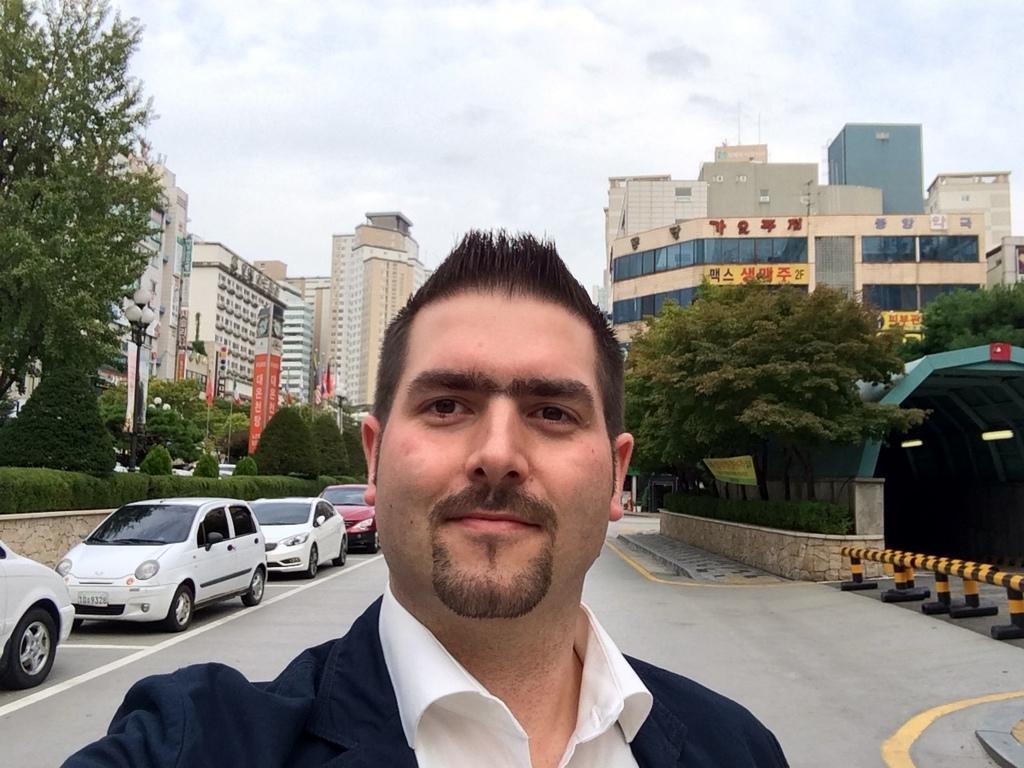How would you summarize this image in a sentence or two? In the middle of the image we can see a man, behind to him we can find few cars, trees, metal rods and lights, in the background we can see few poles, hoardings and buildings. 